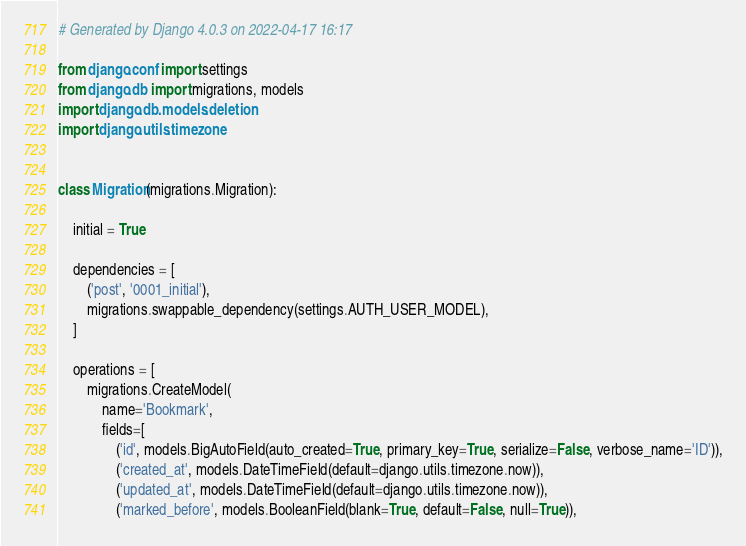<code> <loc_0><loc_0><loc_500><loc_500><_Python_># Generated by Django 4.0.3 on 2022-04-17 16:17

from django.conf import settings
from django.db import migrations, models
import django.db.models.deletion
import django.utils.timezone


class Migration(migrations.Migration):

    initial = True

    dependencies = [
        ('post', '0001_initial'),
        migrations.swappable_dependency(settings.AUTH_USER_MODEL),
    ]

    operations = [
        migrations.CreateModel(
            name='Bookmark',
            fields=[
                ('id', models.BigAutoField(auto_created=True, primary_key=True, serialize=False, verbose_name='ID')),
                ('created_at', models.DateTimeField(default=django.utils.timezone.now)),
                ('updated_at', models.DateTimeField(default=django.utils.timezone.now)),
                ('marked_before', models.BooleanField(blank=True, default=False, null=True)),</code> 